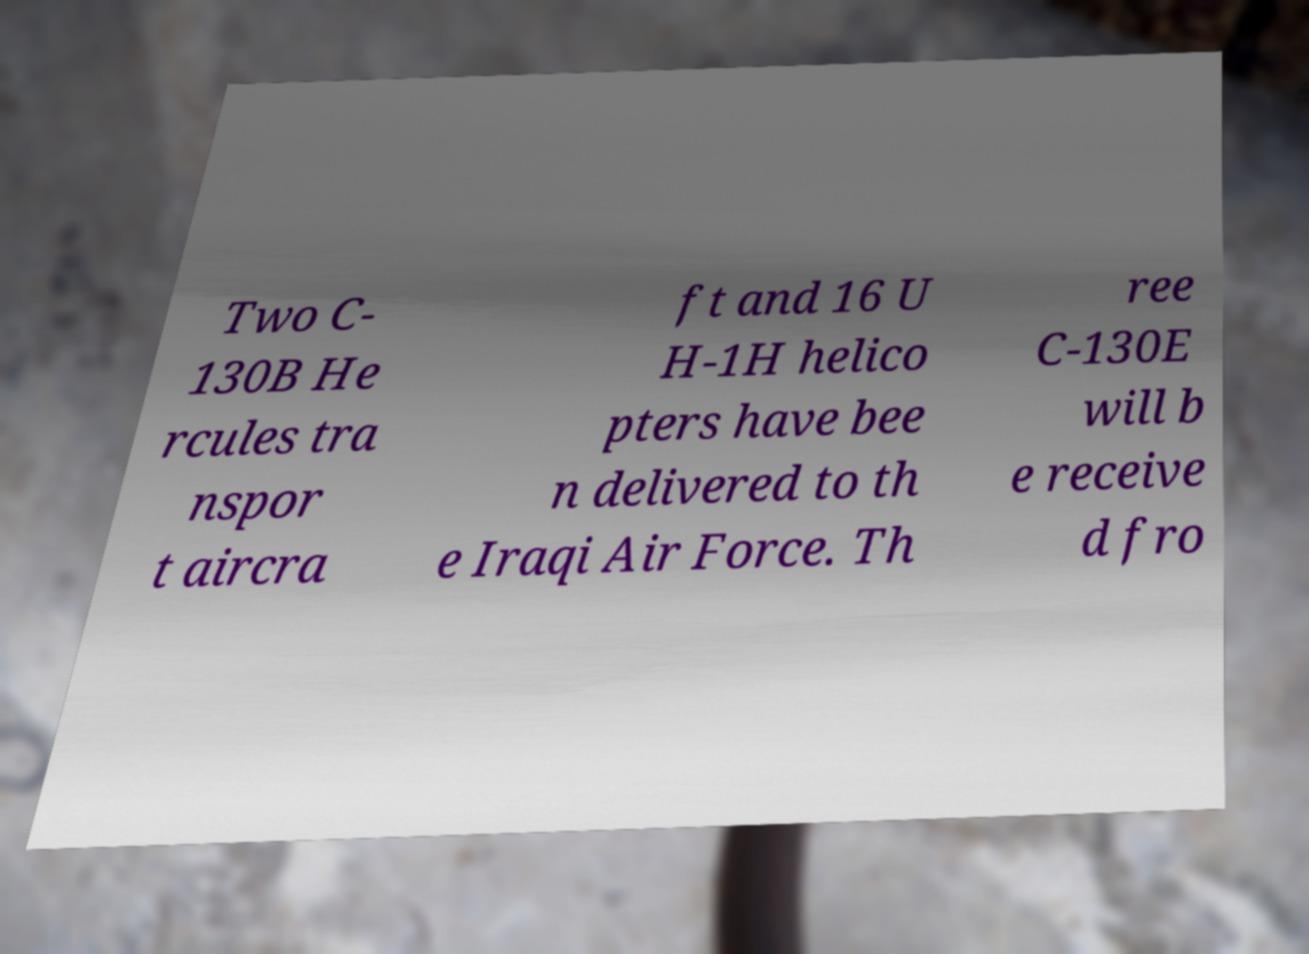Please read and relay the text visible in this image. What does it say? Two C- 130B He rcules tra nspor t aircra ft and 16 U H-1H helico pters have bee n delivered to th e Iraqi Air Force. Th ree C-130E will b e receive d fro 